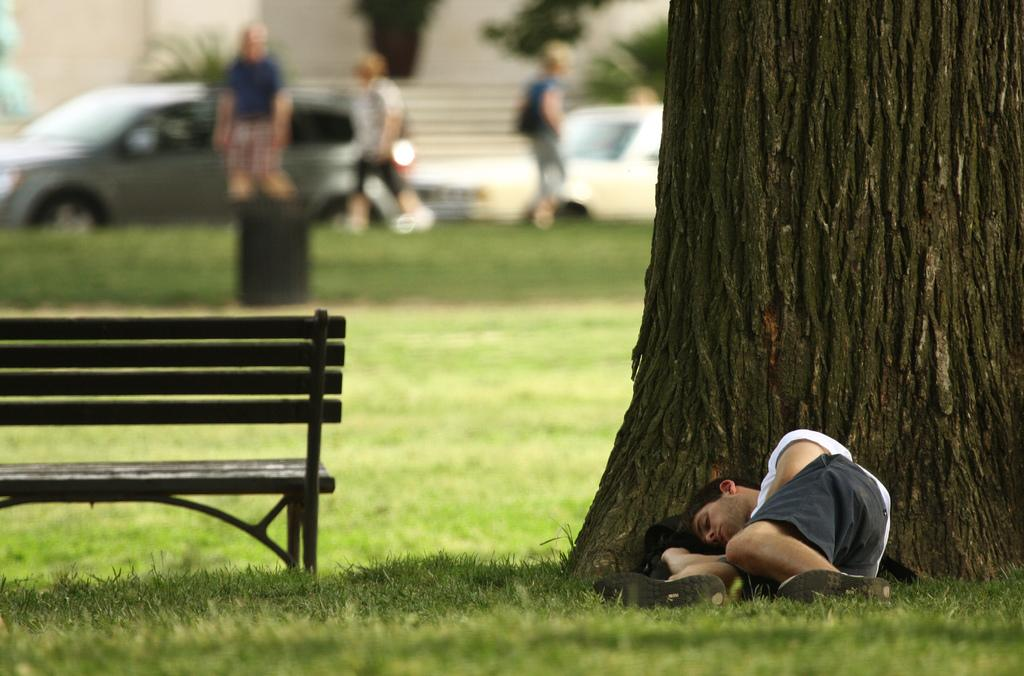What is the person in the image doing? The person is lying on a grass field. What part of a tree can be seen in the image? The bark of a tree is visible in the image. What type of seating is present in the image? There is a bench in the image. How many people are present in the image? There are people present in the image. What can be seen in the background of the image? Plants and vehicles are visible in the background of the image. Can you hear the person's heartbeat in the image? There is no audible information in the image, so it is not possible to hear the person's heartbeat. 